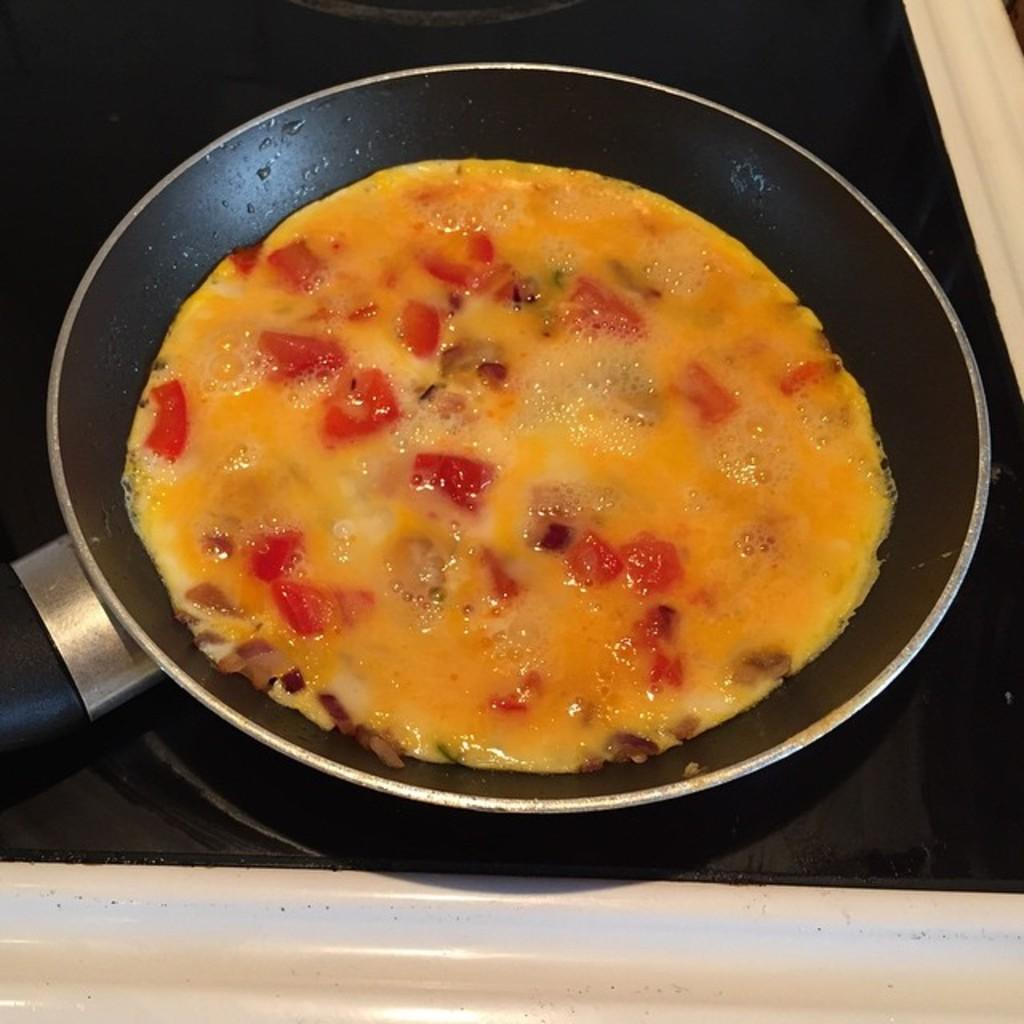What is in the pan that is visible in the image? There is a dish in the pan that is visible in the image. What type of stove is present in the image? There is an induction stove in the image. What type of writing can be seen on the dish in the image? There is no writing visible on the dish in the image. What is the value of the dish in the image? The value of the dish cannot be determined from the image alone. 